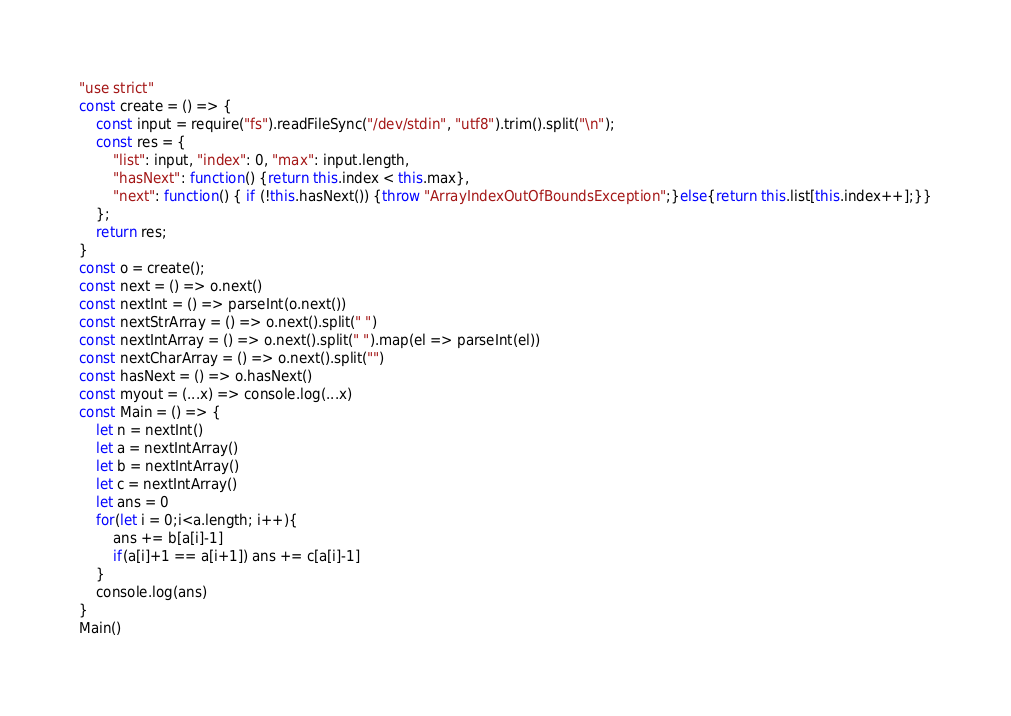<code> <loc_0><loc_0><loc_500><loc_500><_JavaScript_>"use strict"
const create = () => {
    const input = require("fs").readFileSync("/dev/stdin", "utf8").trim().split("\n");
    const res = {
        "list": input, "index": 0, "max": input.length,
        "hasNext": function() {return this.index < this.max},
        "next": function() { if (!this.hasNext()) {throw "ArrayIndexOutOfBoundsException";}else{return this.list[this.index++];}}
    };
    return res;
}
const o = create();
const next = () => o.next()
const nextInt = () => parseInt(o.next())
const nextStrArray = () => o.next().split(" ")
const nextIntArray = () => o.next().split(" ").map(el => parseInt(el))
const nextCharArray = () => o.next().split("")
const hasNext = () => o.hasNext()
const myout = (...x) => console.log(...x)
const Main = () => {
    let n = nextInt()
    let a = nextIntArray()
    let b = nextIntArray()
    let c = nextIntArray()
    let ans = 0
    for(let i = 0;i<a.length; i++){
        ans += b[a[i]-1]
        if(a[i]+1 == a[i+1]) ans += c[a[i]-1]
    }
    console.log(ans)
}
Main()
</code> 